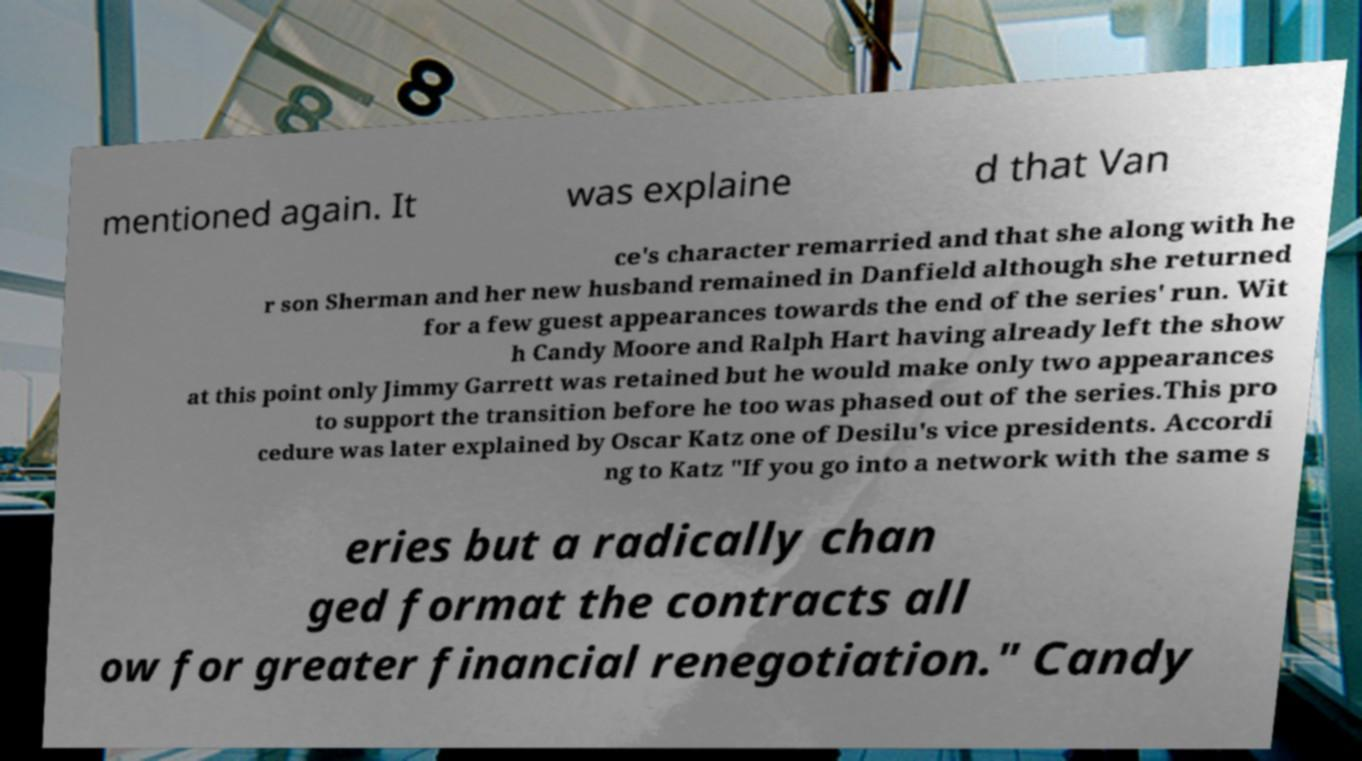I need the written content from this picture converted into text. Can you do that? mentioned again. It was explaine d that Van ce's character remarried and that she along with he r son Sherman and her new husband remained in Danfield although she returned for a few guest appearances towards the end of the series' run. Wit h Candy Moore and Ralph Hart having already left the show at this point only Jimmy Garrett was retained but he would make only two appearances to support the transition before he too was phased out of the series.This pro cedure was later explained by Oscar Katz one of Desilu's vice presidents. Accordi ng to Katz "If you go into a network with the same s eries but a radically chan ged format the contracts all ow for greater financial renegotiation." Candy 